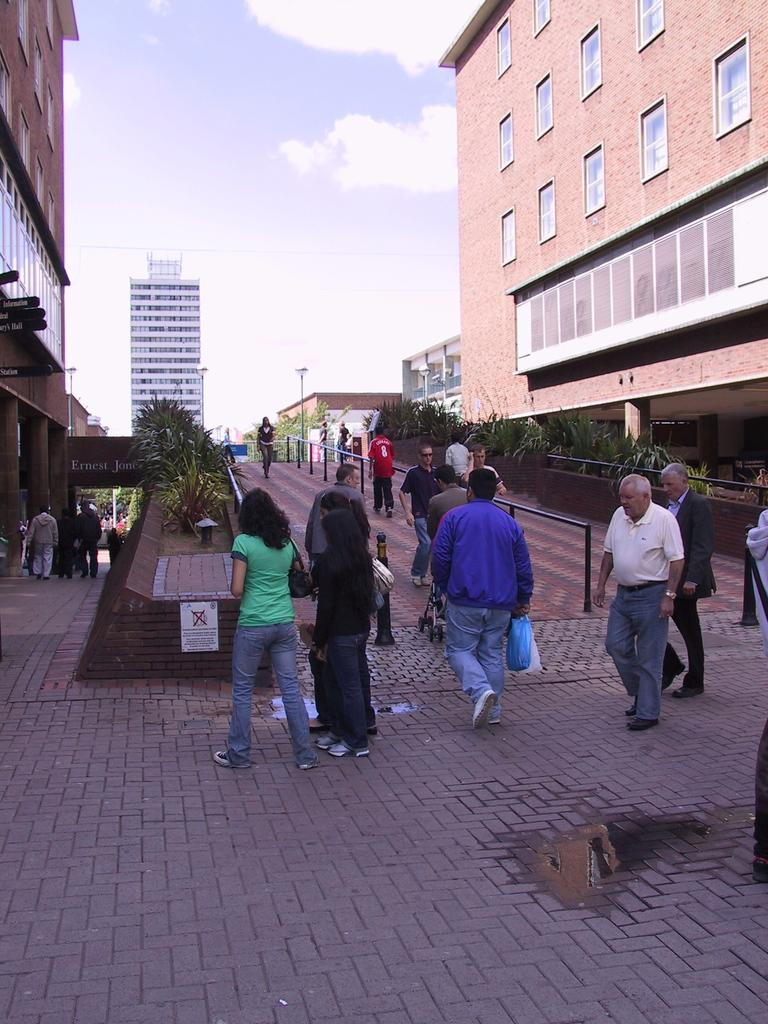How many people can be seen in the image? There are many people in the image. What are the people doing in the image? The people are walking on a foot over bridge. What can be seen on either side of the foot over bridge? There are buildings on either side of the foot over bridge. What is visible above the foot over bridge? The sky is visible above the foot over bridge. What can be observed in the sky? Clouds are present in the sky. Where is the toy located in the image? There is no toy present in the image. What type of root can be seen growing on the foot over bridge? There are no roots visible on the foot over bridge; it is a man-made structure. 